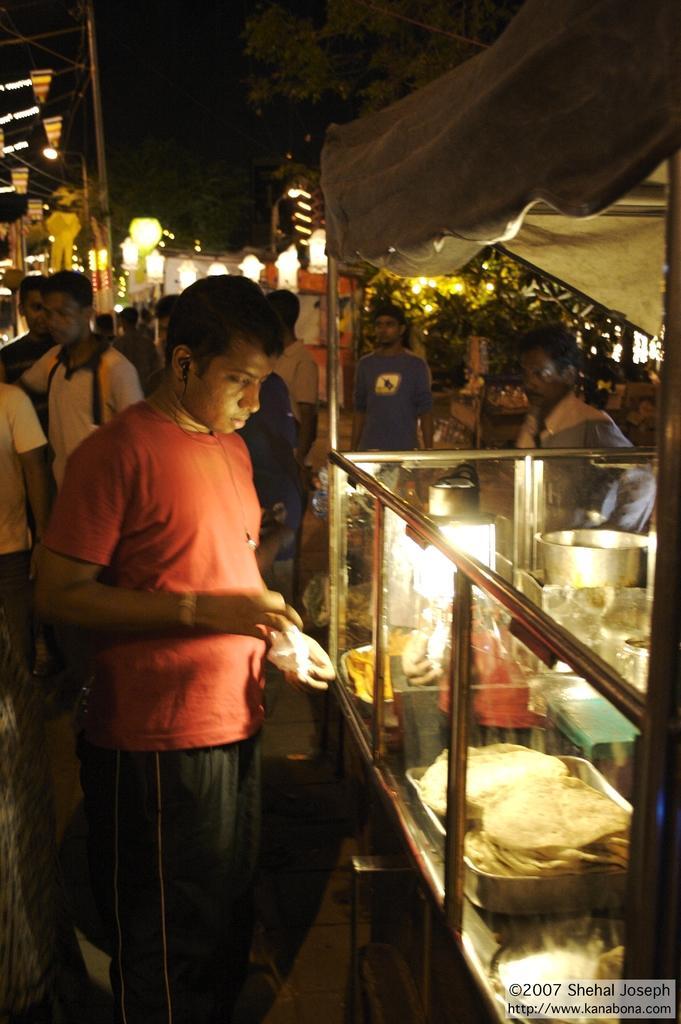Describe this image in one or two sentences. Here we can see few persons and there is a stall. Here we can see food, tray, and a bowl. In the background we can see lights, poles, and trees. 